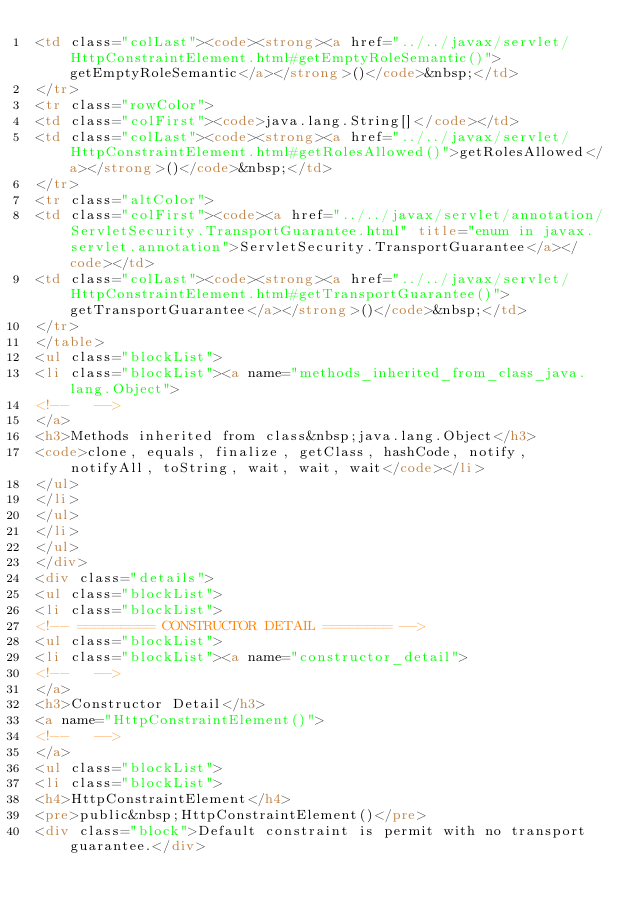<code> <loc_0><loc_0><loc_500><loc_500><_HTML_><td class="colLast"><code><strong><a href="../../javax/servlet/HttpConstraintElement.html#getEmptyRoleSemantic()">getEmptyRoleSemantic</a></strong>()</code>&nbsp;</td>
</tr>
<tr class="rowColor">
<td class="colFirst"><code>java.lang.String[]</code></td>
<td class="colLast"><code><strong><a href="../../javax/servlet/HttpConstraintElement.html#getRolesAllowed()">getRolesAllowed</a></strong>()</code>&nbsp;</td>
</tr>
<tr class="altColor">
<td class="colFirst"><code><a href="../../javax/servlet/annotation/ServletSecurity.TransportGuarantee.html" title="enum in javax.servlet.annotation">ServletSecurity.TransportGuarantee</a></code></td>
<td class="colLast"><code><strong><a href="../../javax/servlet/HttpConstraintElement.html#getTransportGuarantee()">getTransportGuarantee</a></strong>()</code>&nbsp;</td>
</tr>
</table>
<ul class="blockList">
<li class="blockList"><a name="methods_inherited_from_class_java.lang.Object">
<!--   -->
</a>
<h3>Methods inherited from class&nbsp;java.lang.Object</h3>
<code>clone, equals, finalize, getClass, hashCode, notify, notifyAll, toString, wait, wait, wait</code></li>
</ul>
</li>
</ul>
</li>
</ul>
</div>
<div class="details">
<ul class="blockList">
<li class="blockList">
<!-- ========= CONSTRUCTOR DETAIL ======== -->
<ul class="blockList">
<li class="blockList"><a name="constructor_detail">
<!--   -->
</a>
<h3>Constructor Detail</h3>
<a name="HttpConstraintElement()">
<!--   -->
</a>
<ul class="blockList">
<li class="blockList">
<h4>HttpConstraintElement</h4>
<pre>public&nbsp;HttpConstraintElement()</pre>
<div class="block">Default constraint is permit with no transport guarantee.</div></code> 